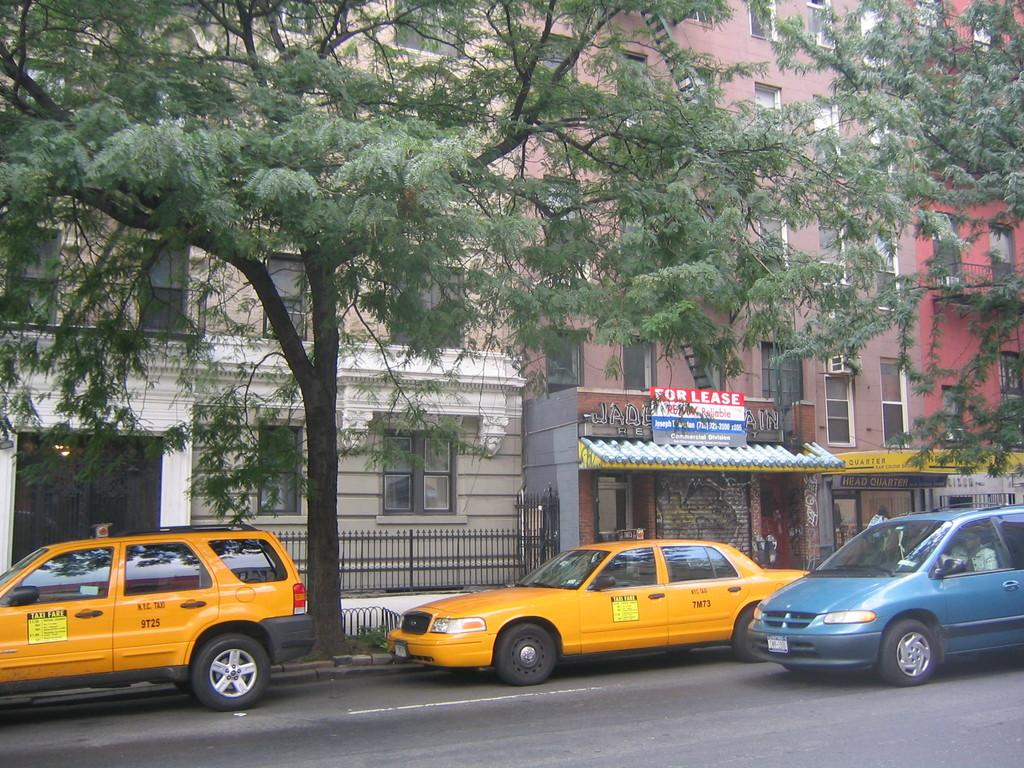<image>
Summarize the visual content of the image. Several cars are on the street in front of a building with a For Lease sign on it. 